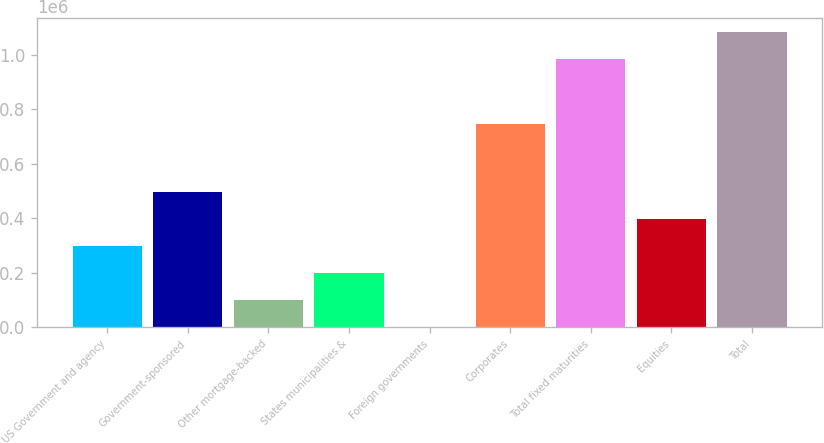<chart> <loc_0><loc_0><loc_500><loc_500><bar_chart><fcel>US Government and agency<fcel>Government-sponsored<fcel>Other mortgage-backed<fcel>States municipalities &<fcel>Foreign governments<fcel>Corporates<fcel>Total fixed maturities<fcel>Equities<fcel>Total<nl><fcel>298564<fcel>497604<fcel>99523.8<fcel>199044<fcel>3.64<fcel>748183<fcel>984648<fcel>398084<fcel>1.08417e+06<nl></chart> 